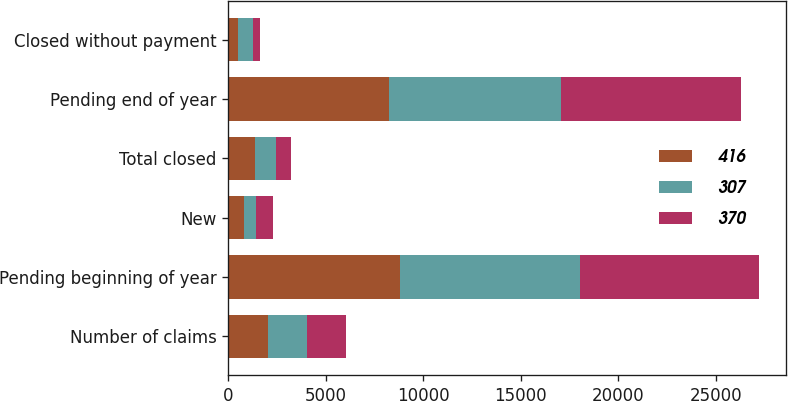<chart> <loc_0><loc_0><loc_500><loc_500><stacked_bar_chart><ecel><fcel>Number of claims<fcel>Pending beginning of year<fcel>New<fcel>Total closed<fcel>Pending end of year<fcel>Closed without payment<nl><fcel>416<fcel>2009<fcel>8780<fcel>814<fcel>1342<fcel>8252<fcel>469<nl><fcel>307<fcel>2008<fcel>9256<fcel>601<fcel>1077<fcel>8780<fcel>800<nl><fcel>370<fcel>2007<fcel>9175<fcel>876<fcel>795<fcel>9256<fcel>364<nl></chart> 